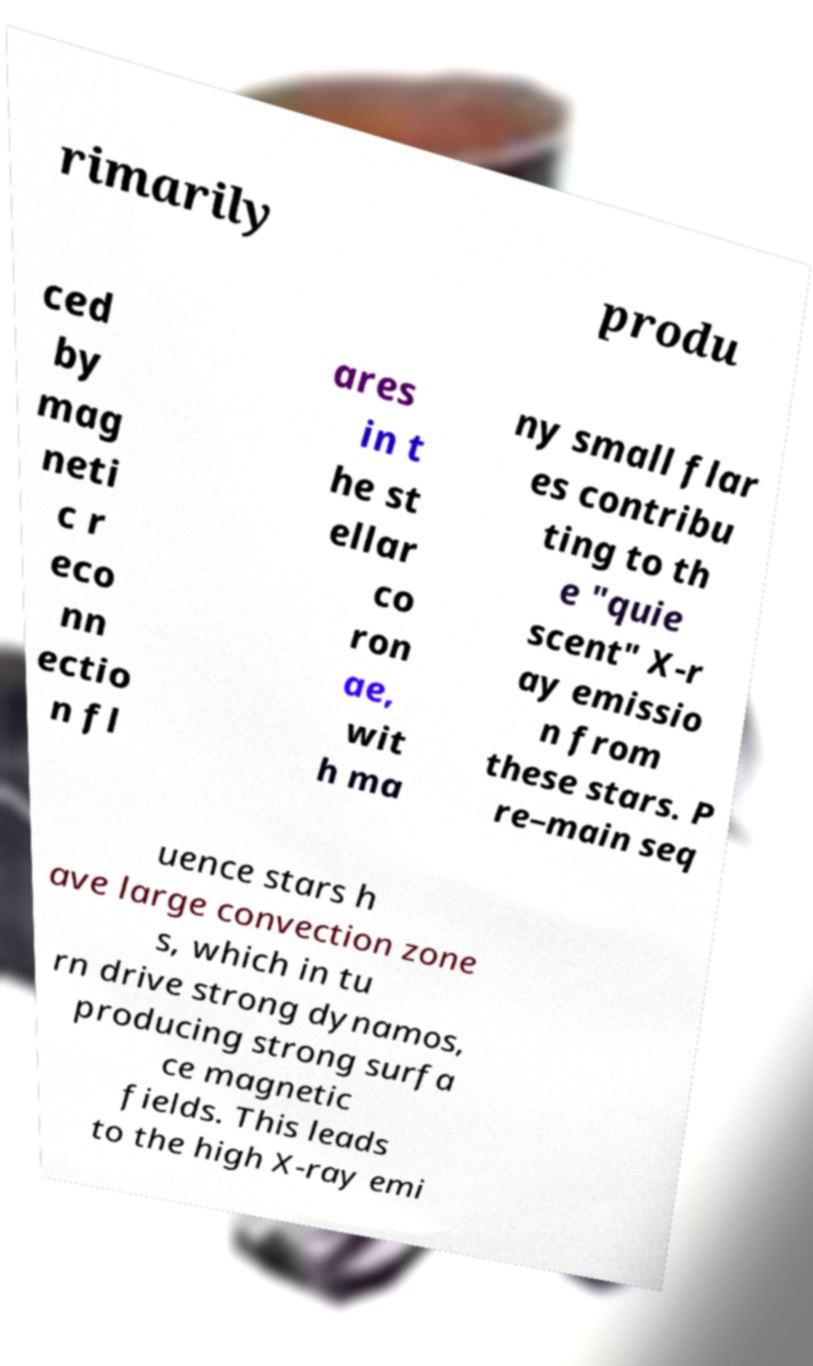Can you read and provide the text displayed in the image?This photo seems to have some interesting text. Can you extract and type it out for me? rimarily produ ced by mag neti c r eco nn ectio n fl ares in t he st ellar co ron ae, wit h ma ny small flar es contribu ting to th e "quie scent" X-r ay emissio n from these stars. P re–main seq uence stars h ave large convection zone s, which in tu rn drive strong dynamos, producing strong surfa ce magnetic fields. This leads to the high X-ray emi 